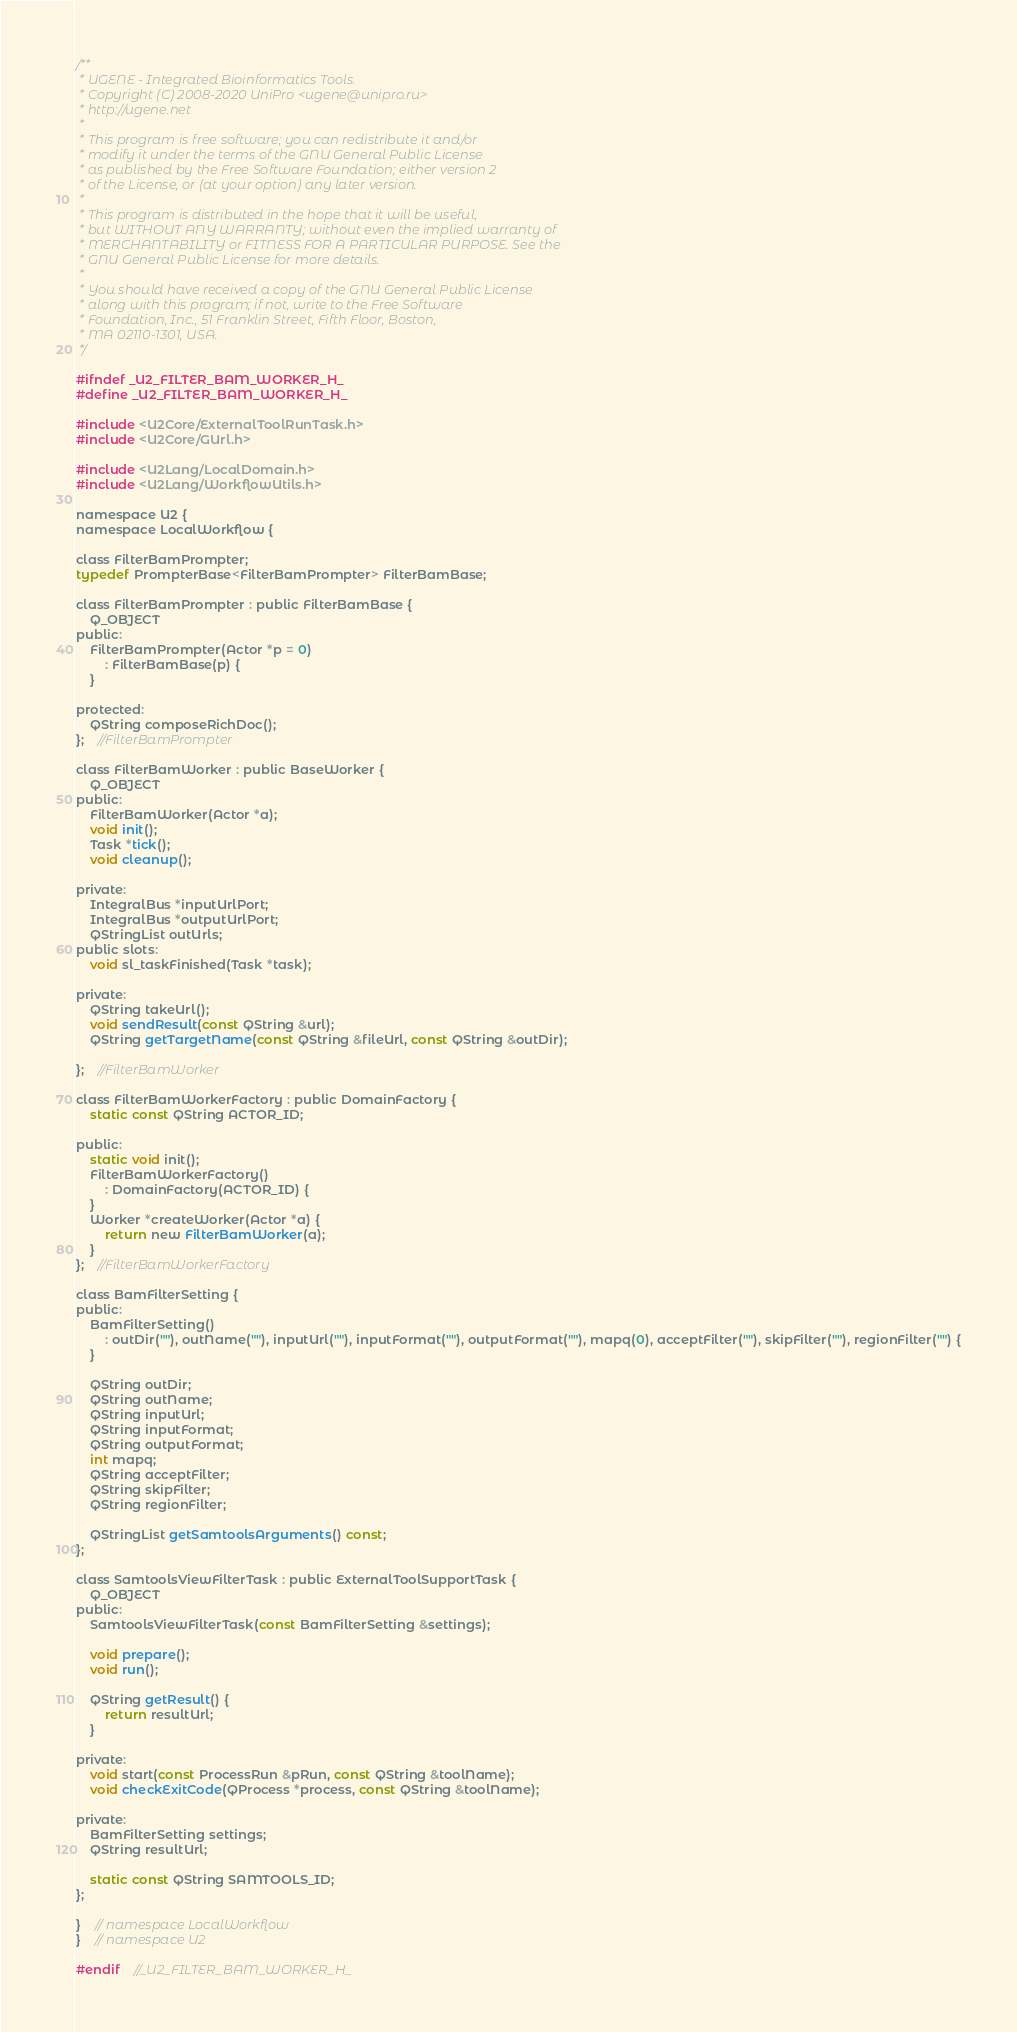<code> <loc_0><loc_0><loc_500><loc_500><_C_>/**
 * UGENE - Integrated Bioinformatics Tools.
 * Copyright (C) 2008-2020 UniPro <ugene@unipro.ru>
 * http://ugene.net
 *
 * This program is free software; you can redistribute it and/or
 * modify it under the terms of the GNU General Public License
 * as published by the Free Software Foundation; either version 2
 * of the License, or (at your option) any later version.
 *
 * This program is distributed in the hope that it will be useful,
 * but WITHOUT ANY WARRANTY; without even the implied warranty of
 * MERCHANTABILITY or FITNESS FOR A PARTICULAR PURPOSE. See the
 * GNU General Public License for more details.
 *
 * You should have received a copy of the GNU General Public License
 * along with this program; if not, write to the Free Software
 * Foundation, Inc., 51 Franklin Street, Fifth Floor, Boston,
 * MA 02110-1301, USA.
 */

#ifndef _U2_FILTER_BAM_WORKER_H_
#define _U2_FILTER_BAM_WORKER_H_

#include <U2Core/ExternalToolRunTask.h>
#include <U2Core/GUrl.h>

#include <U2Lang/LocalDomain.h>
#include <U2Lang/WorkflowUtils.h>

namespace U2 {
namespace LocalWorkflow {

class FilterBamPrompter;
typedef PrompterBase<FilterBamPrompter> FilterBamBase;

class FilterBamPrompter : public FilterBamBase {
    Q_OBJECT
public:
    FilterBamPrompter(Actor *p = 0)
        : FilterBamBase(p) {
    }

protected:
    QString composeRichDoc();
};    //FilterBamPrompter

class FilterBamWorker : public BaseWorker {
    Q_OBJECT
public:
    FilterBamWorker(Actor *a);
    void init();
    Task *tick();
    void cleanup();

private:
    IntegralBus *inputUrlPort;
    IntegralBus *outputUrlPort;
    QStringList outUrls;
public slots:
    void sl_taskFinished(Task *task);

private:
    QString takeUrl();
    void sendResult(const QString &url);
    QString getTargetName(const QString &fileUrl, const QString &outDir);

};    //FilterBamWorker

class FilterBamWorkerFactory : public DomainFactory {
    static const QString ACTOR_ID;

public:
    static void init();
    FilterBamWorkerFactory()
        : DomainFactory(ACTOR_ID) {
    }
    Worker *createWorker(Actor *a) {
        return new FilterBamWorker(a);
    }
};    //FilterBamWorkerFactory

class BamFilterSetting {
public:
    BamFilterSetting()
        : outDir(""), outName(""), inputUrl(""), inputFormat(""), outputFormat(""), mapq(0), acceptFilter(""), skipFilter(""), regionFilter("") {
    }

    QString outDir;
    QString outName;
    QString inputUrl;
    QString inputFormat;
    QString outputFormat;
    int mapq;
    QString acceptFilter;
    QString skipFilter;
    QString regionFilter;

    QStringList getSamtoolsArguments() const;
};

class SamtoolsViewFilterTask : public ExternalToolSupportTask {
    Q_OBJECT
public:
    SamtoolsViewFilterTask(const BamFilterSetting &settings);

    void prepare();
    void run();

    QString getResult() {
        return resultUrl;
    }

private:
    void start(const ProcessRun &pRun, const QString &toolName);
    void checkExitCode(QProcess *process, const QString &toolName);

private:
    BamFilterSetting settings;
    QString resultUrl;

    static const QString SAMTOOLS_ID;
};

}    // namespace LocalWorkflow
}    // namespace U2

#endif    //_U2_FILTER_BAM_WORKER_H_
</code> 